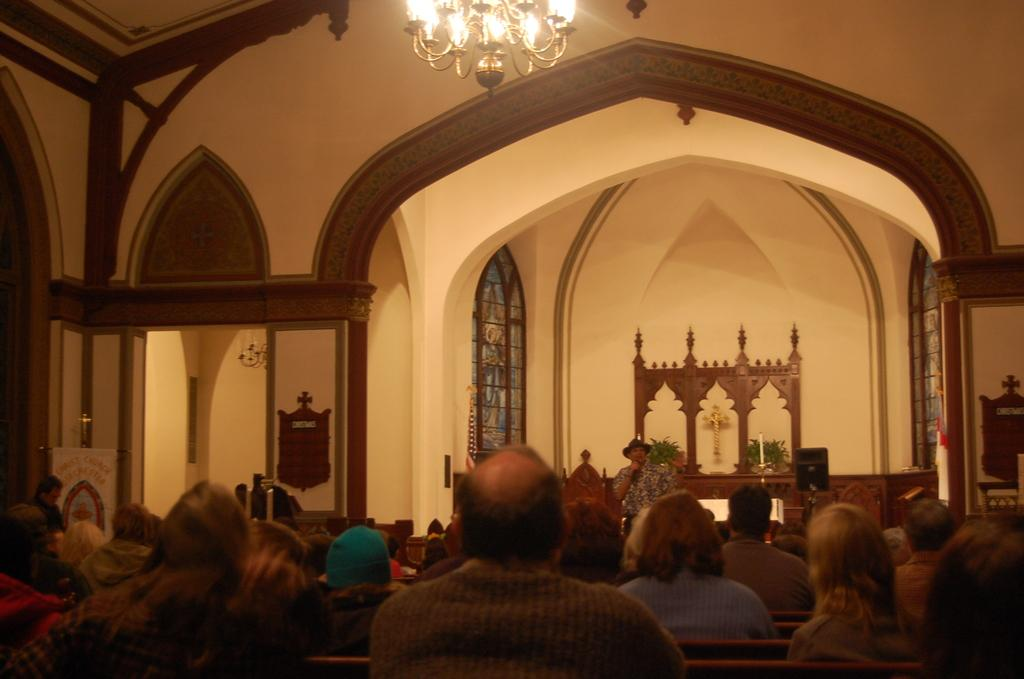What is the man in the image doing? The man is standing in the image and holding a microphone. What can be seen in the image besides the man? There are people sitting in the image, as well as walls, a window, lights, and a chandelier. What might the man be using the microphone for? The man might be using the microphone for speaking or singing in front of the audience. Can you describe the lighting in the image? The image features lights and a chandelier, which provide illumination. What thrill does the night bring to the man in the image? There is no mention of night or thrill in the image. The image only shows a man standing with a microphone, people sitting, walls, a window, lights, and a chandelier. 